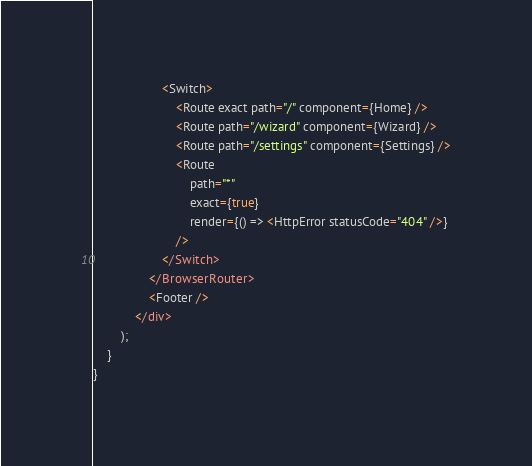<code> <loc_0><loc_0><loc_500><loc_500><_JavaScript_>                    <Switch>
                        <Route exact path="/" component={Home} />
                        <Route path="/wizard" component={Wizard} />
                        <Route path="/settings" component={Settings} />
                        <Route
                            path="*"
                            exact={true}
                            render={() => <HttpError statusCode="404" />}
                        />
                    </Switch>
                </BrowserRouter>
                <Footer />
            </div>
        );
    }
}
</code> 